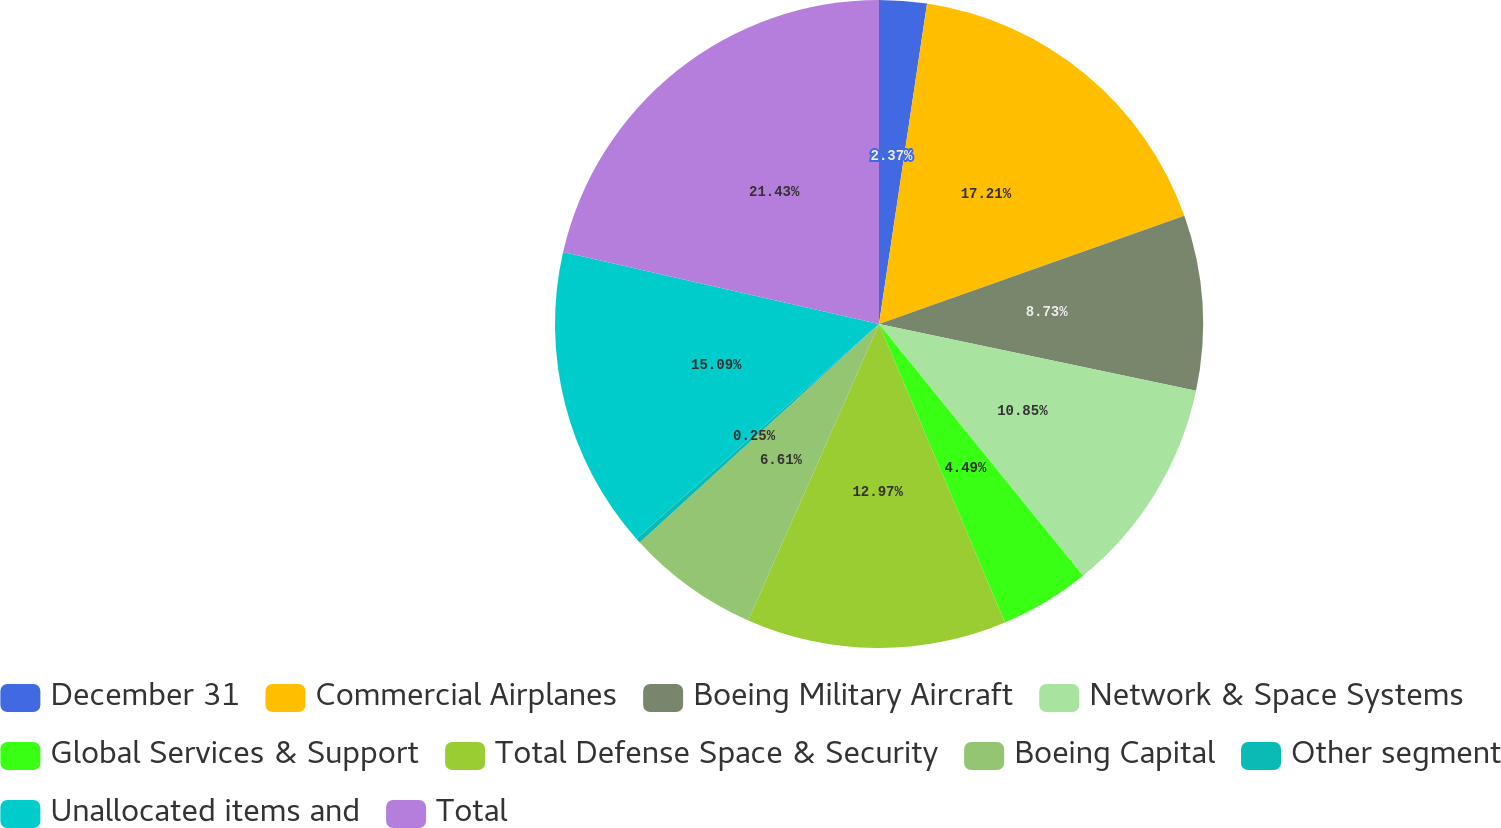Convert chart to OTSL. <chart><loc_0><loc_0><loc_500><loc_500><pie_chart><fcel>December 31<fcel>Commercial Airplanes<fcel>Boeing Military Aircraft<fcel>Network & Space Systems<fcel>Global Services & Support<fcel>Total Defense Space & Security<fcel>Boeing Capital<fcel>Other segment<fcel>Unallocated items and<fcel>Total<nl><fcel>2.37%<fcel>17.21%<fcel>8.73%<fcel>10.85%<fcel>4.49%<fcel>12.97%<fcel>6.61%<fcel>0.25%<fcel>15.09%<fcel>21.44%<nl></chart> 